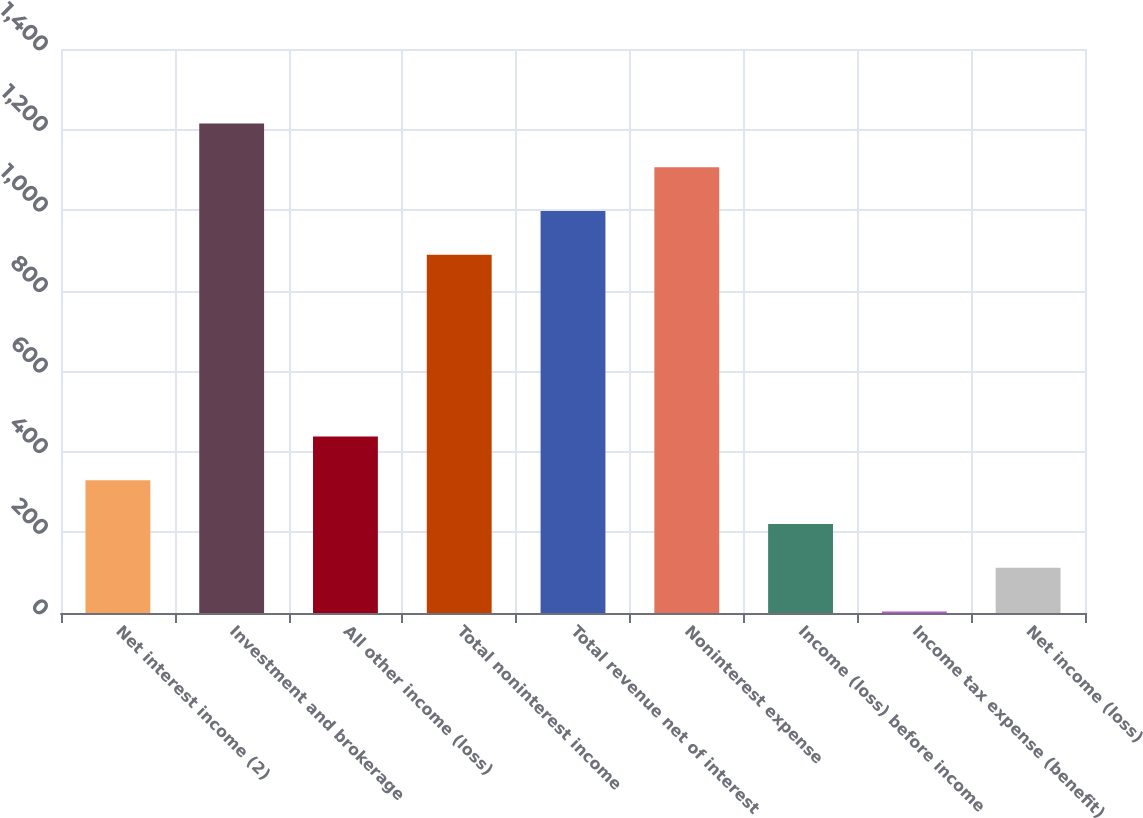<chart> <loc_0><loc_0><loc_500><loc_500><bar_chart><fcel>Net interest income (2)<fcel>Investment and brokerage<fcel>All other income (loss)<fcel>Total noninterest income<fcel>Total revenue net of interest<fcel>Noninterest expense<fcel>Income (loss) before income<fcel>Income tax expense (benefit)<fcel>Net income (loss)<nl><fcel>329.8<fcel>1214.8<fcel>438.4<fcel>889<fcel>997.6<fcel>1106.2<fcel>221.2<fcel>4<fcel>112.6<nl></chart> 